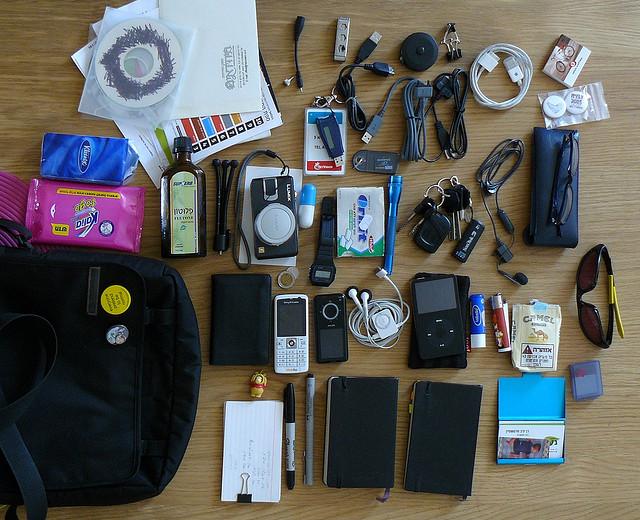Is there a phone here?
Short answer required. Yes. What color are the ends of sunglasses?
Write a very short answer. Yellow. What are objects laid on?
Be succinct. Table. How many batteries are in the charger?
Be succinct. 0. How many devices are in the mess?
Short answer required. 10. 